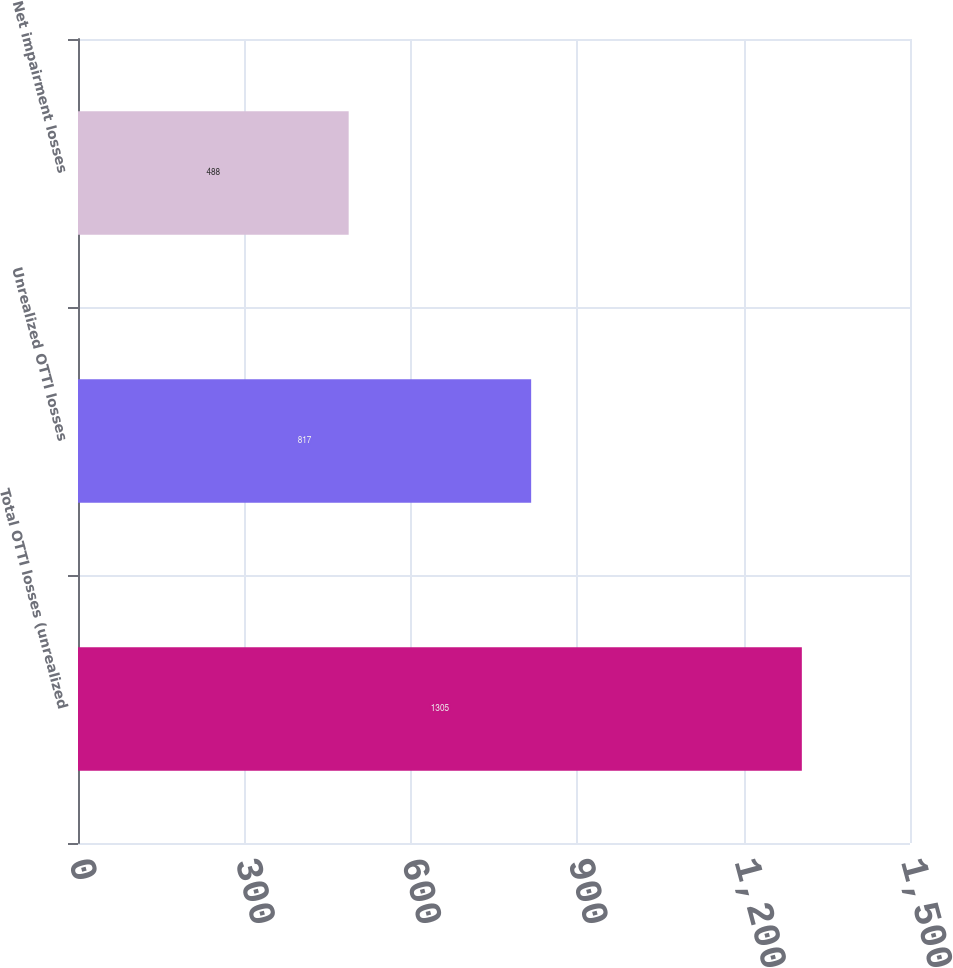<chart> <loc_0><loc_0><loc_500><loc_500><bar_chart><fcel>Total OTTI losses (unrealized<fcel>Unrealized OTTI losses<fcel>Net impairment losses<nl><fcel>1305<fcel>817<fcel>488<nl></chart> 